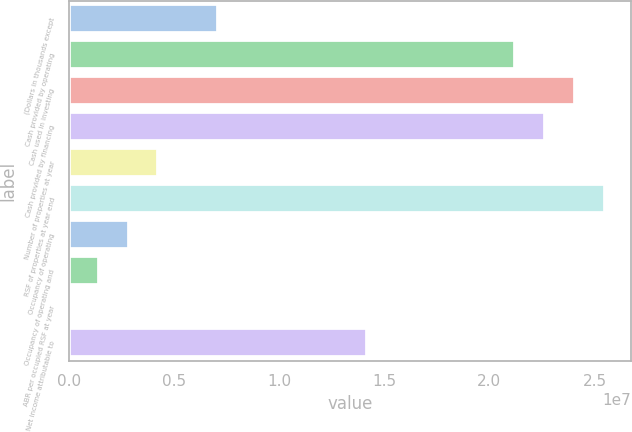Convert chart. <chart><loc_0><loc_0><loc_500><loc_500><bar_chart><fcel>(Dollars in thousands except<fcel>Cash provided by operating<fcel>Cash used in investing<fcel>Cash provided by financing<fcel>Number of properties at year<fcel>RSF of properties at year end<fcel>Occupancy of operating<fcel>Occupancy of operating and<fcel>ABR per occupied RSF at year<fcel>Net income attributable to<nl><fcel>7.07912e+06<fcel>2.12373e+07<fcel>2.40689e+07<fcel>2.26531e+07<fcel>4.24749e+06<fcel>2.54848e+07<fcel>2.83167e+06<fcel>1.41585e+06<fcel>33.95<fcel>1.41582e+07<nl></chart> 